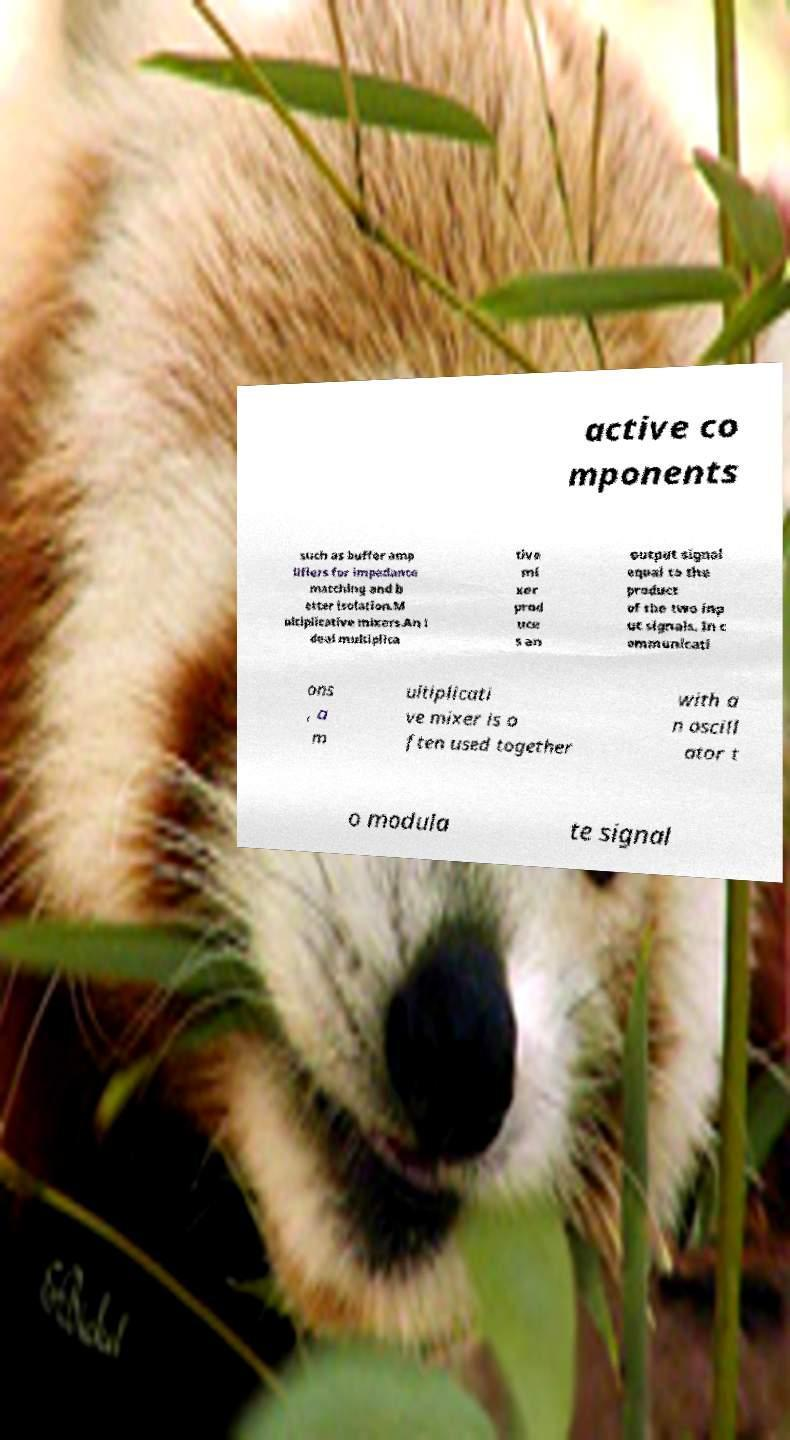Could you extract and type out the text from this image? active co mponents such as buffer amp lifiers for impedance matching and b etter isolation.M ultiplicative mixers.An i deal multiplica tive mi xer prod uce s an output signal equal to the product of the two inp ut signals. In c ommunicati ons , a m ultiplicati ve mixer is o ften used together with a n oscill ator t o modula te signal 